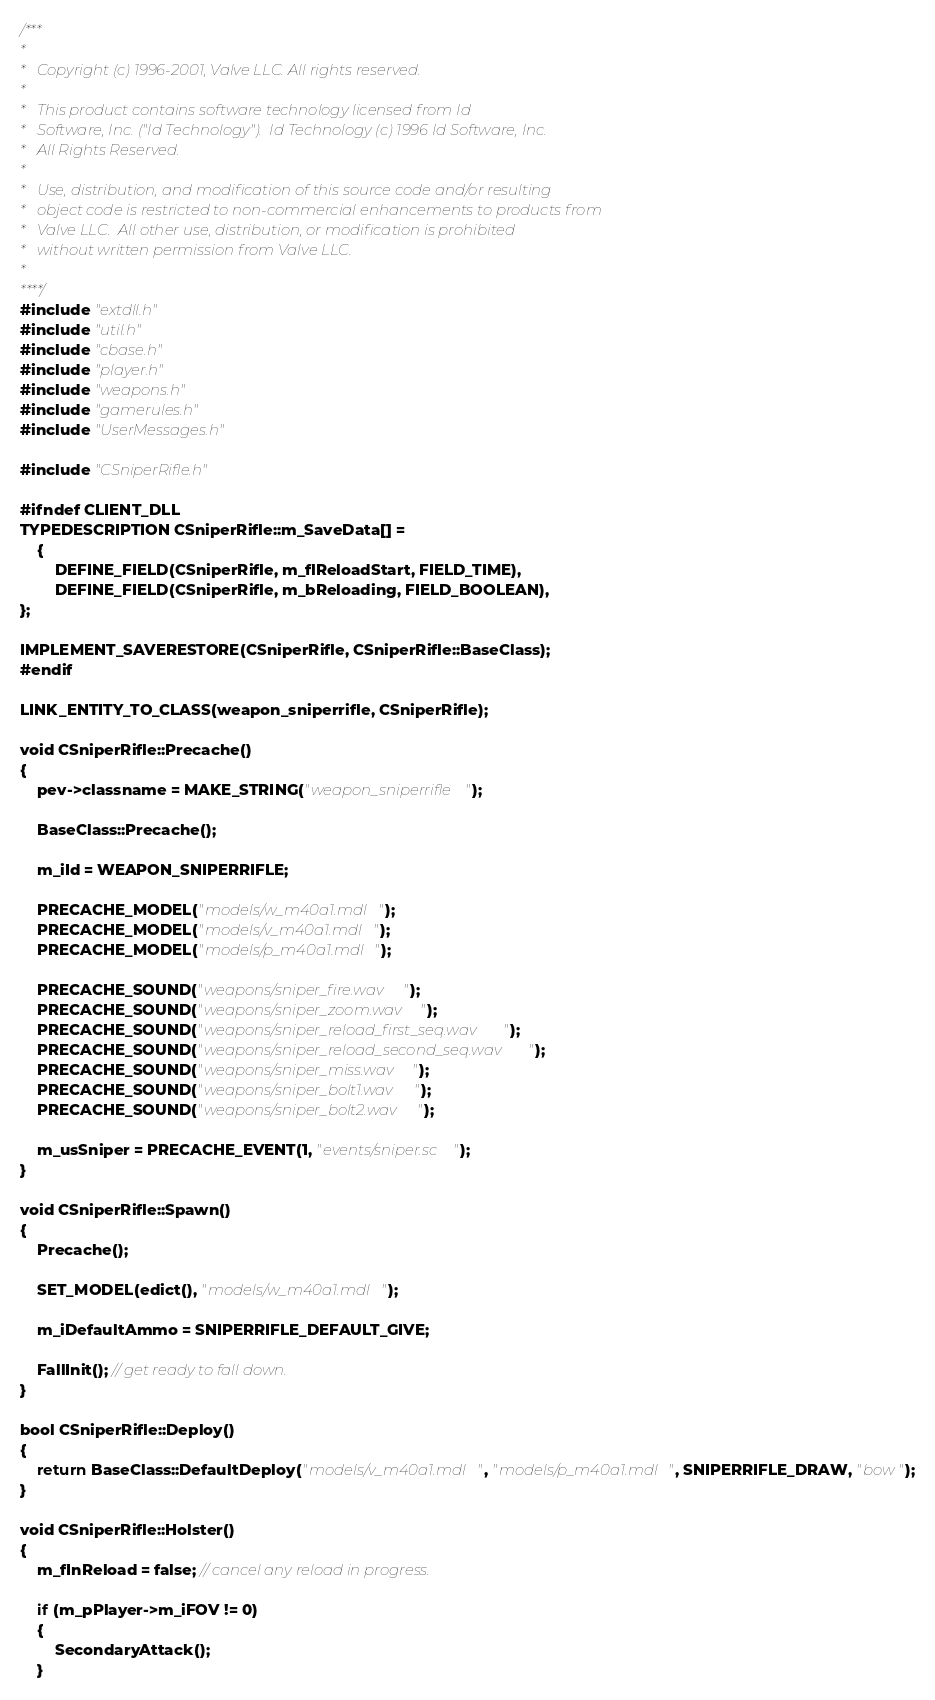Convert code to text. <code><loc_0><loc_0><loc_500><loc_500><_C++_>/***
*
*	Copyright (c) 1996-2001, Valve LLC. All rights reserved.
*
*	This product contains software technology licensed from Id
*	Software, Inc. ("Id Technology").  Id Technology (c) 1996 Id Software, Inc.
*	All Rights Reserved.
*
*   Use, distribution, and modification of this source code and/or resulting
*   object code is restricted to non-commercial enhancements to products from
*   Valve LLC.  All other use, distribution, or modification is prohibited
*   without written permission from Valve LLC.
*
****/
#include "extdll.h"
#include "util.h"
#include "cbase.h"
#include "player.h"
#include "weapons.h"
#include "gamerules.h"
#include "UserMessages.h"

#include "CSniperRifle.h"

#ifndef CLIENT_DLL
TYPEDESCRIPTION CSniperRifle::m_SaveData[] =
	{
		DEFINE_FIELD(CSniperRifle, m_flReloadStart, FIELD_TIME),
		DEFINE_FIELD(CSniperRifle, m_bReloading, FIELD_BOOLEAN),
};

IMPLEMENT_SAVERESTORE(CSniperRifle, CSniperRifle::BaseClass);
#endif

LINK_ENTITY_TO_CLASS(weapon_sniperrifle, CSniperRifle);

void CSniperRifle::Precache()
{
	pev->classname = MAKE_STRING("weapon_sniperrifle");

	BaseClass::Precache();

	m_iId = WEAPON_SNIPERRIFLE;

	PRECACHE_MODEL("models/w_m40a1.mdl");
	PRECACHE_MODEL("models/v_m40a1.mdl");
	PRECACHE_MODEL("models/p_m40a1.mdl");

	PRECACHE_SOUND("weapons/sniper_fire.wav");
	PRECACHE_SOUND("weapons/sniper_zoom.wav");
	PRECACHE_SOUND("weapons/sniper_reload_first_seq.wav");
	PRECACHE_SOUND("weapons/sniper_reload_second_seq.wav");
	PRECACHE_SOUND("weapons/sniper_miss.wav");
	PRECACHE_SOUND("weapons/sniper_bolt1.wav");
	PRECACHE_SOUND("weapons/sniper_bolt2.wav");

	m_usSniper = PRECACHE_EVENT(1, "events/sniper.sc");
}

void CSniperRifle::Spawn()
{
	Precache();

	SET_MODEL(edict(), "models/w_m40a1.mdl");

	m_iDefaultAmmo = SNIPERRIFLE_DEFAULT_GIVE;

	FallInit(); // get ready to fall down.
}

bool CSniperRifle::Deploy()
{
	return BaseClass::DefaultDeploy("models/v_m40a1.mdl", "models/p_m40a1.mdl", SNIPERRIFLE_DRAW, "bow");
}

void CSniperRifle::Holster()
{
	m_fInReload = false; // cancel any reload in progress.

	if (m_pPlayer->m_iFOV != 0)
	{
		SecondaryAttack();
	}
</code> 